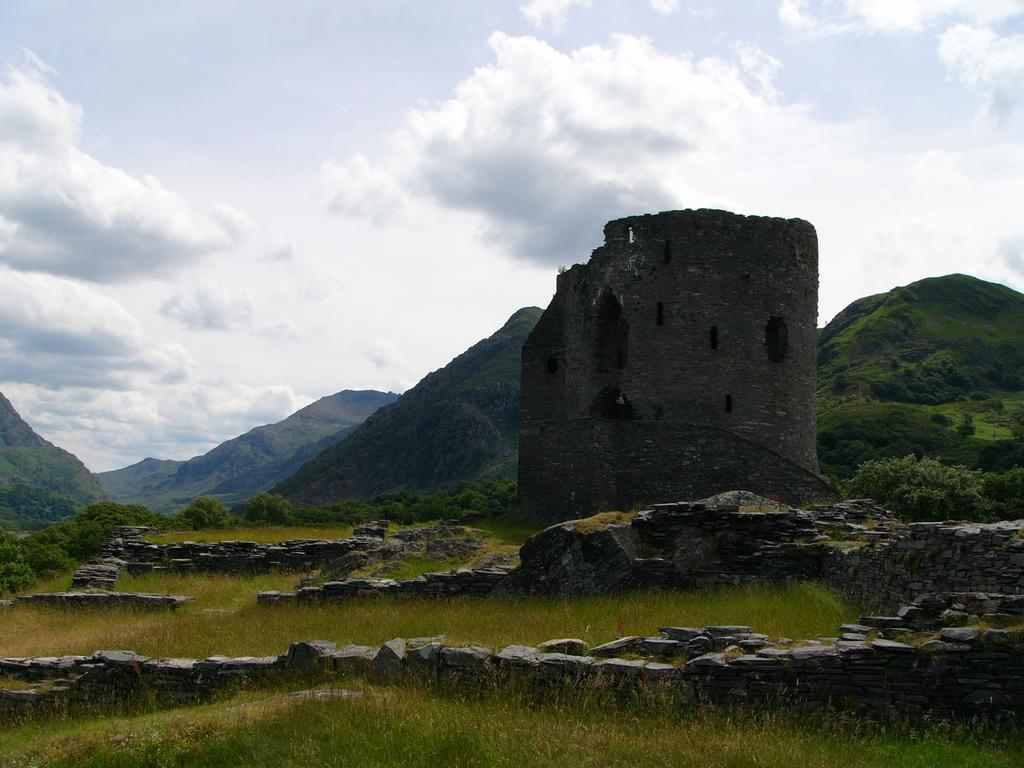What type of structure is present in the image? There is a castle in the image. What material is used to build the castle? The castle is made of stones, as seen in the image. What type of terrain is visible in the image? There are hills in the image, along with grass. What is visible in the sky in the image? The sky is visible in the image, and it contains clouds. Can you see a giraffe kicking a soccer ball on the grass in the image? No, there is no giraffe or soccer ball present in the image. 